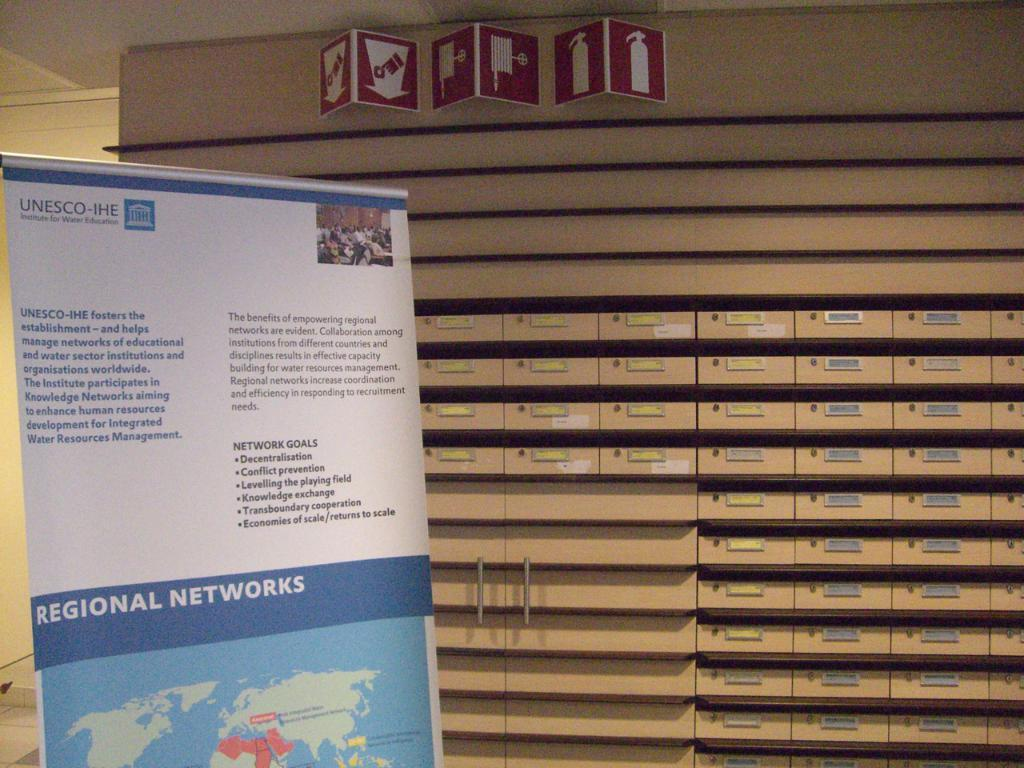Provide a one-sentence caption for the provided image. A UNESCO panel showing the regional networks map. 